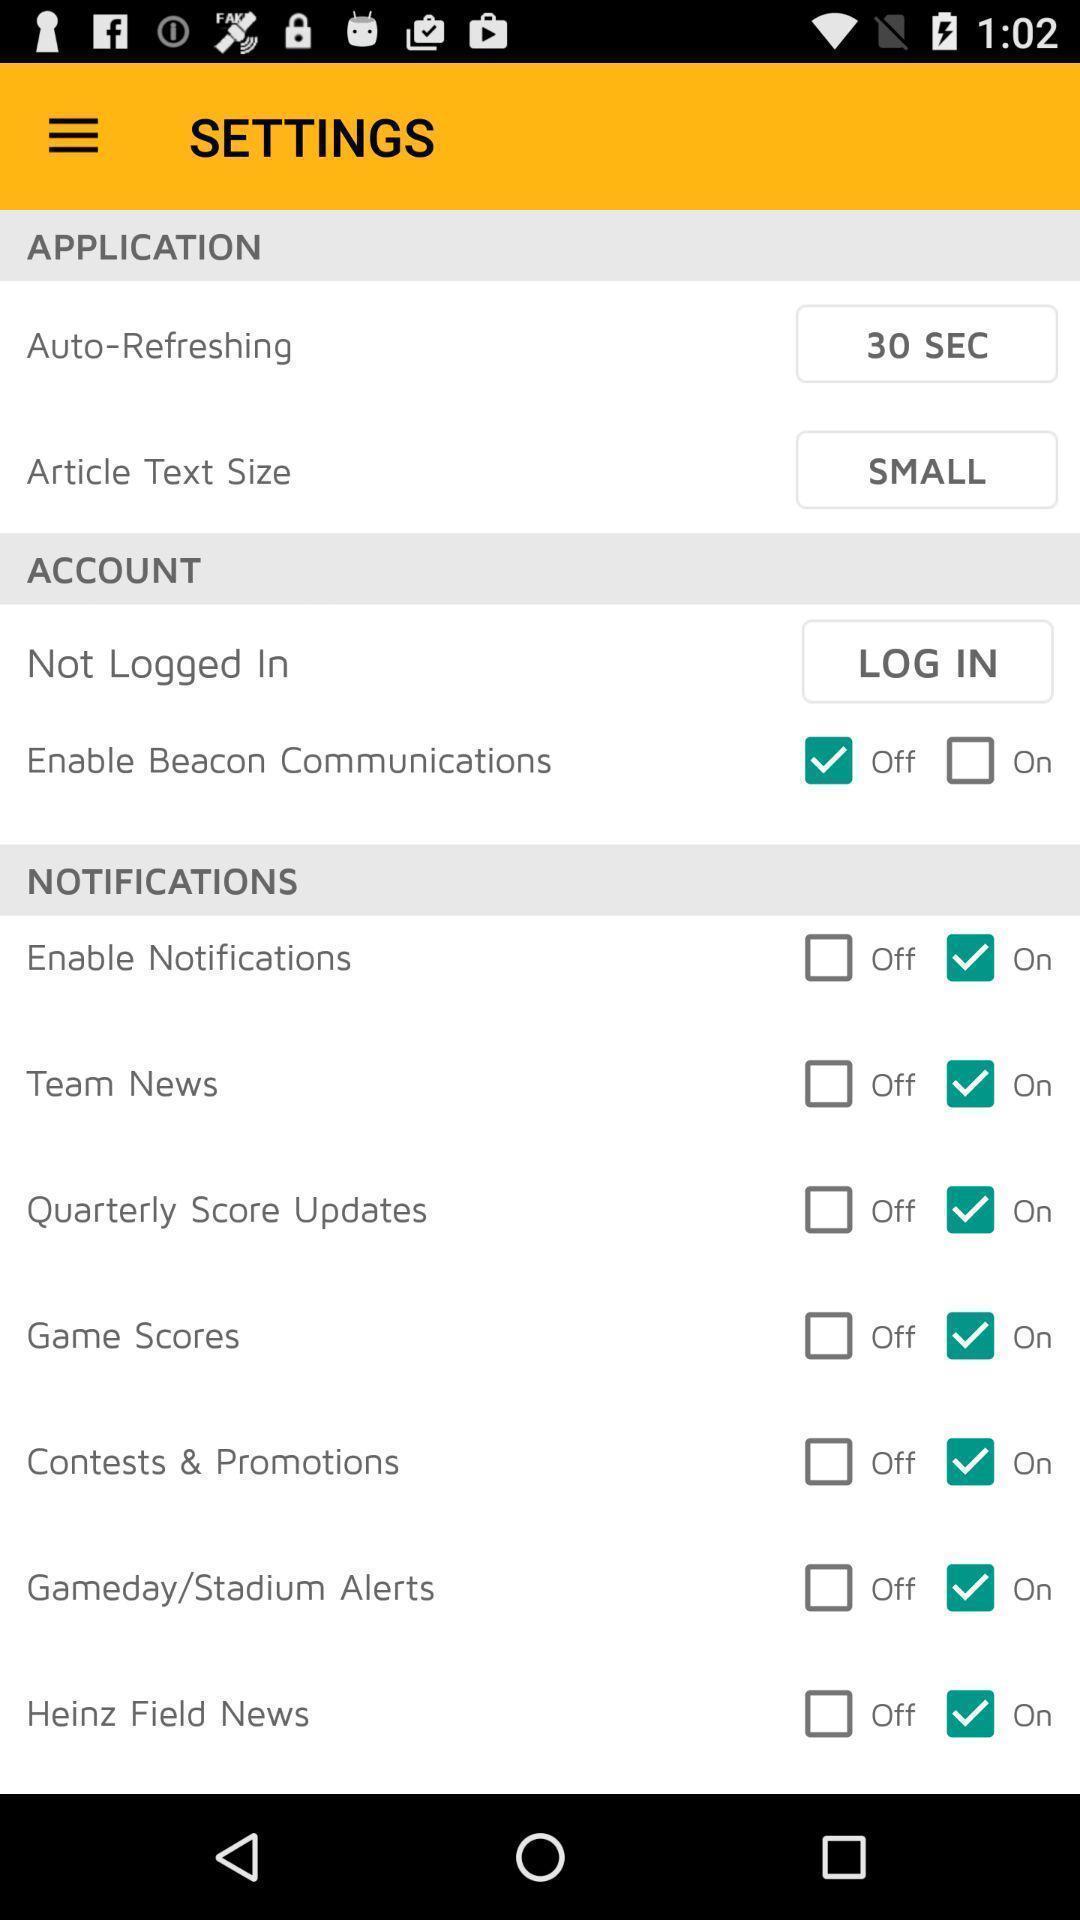Summarize the information in this screenshot. Settings page. 